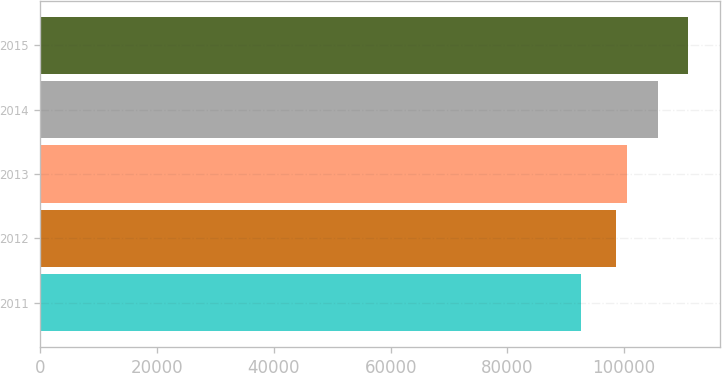<chart> <loc_0><loc_0><loc_500><loc_500><bar_chart><fcel>2011<fcel>2012<fcel>2013<fcel>2014<fcel>2015<nl><fcel>92650<fcel>98650<fcel>100475<fcel>105750<fcel>110900<nl></chart> 